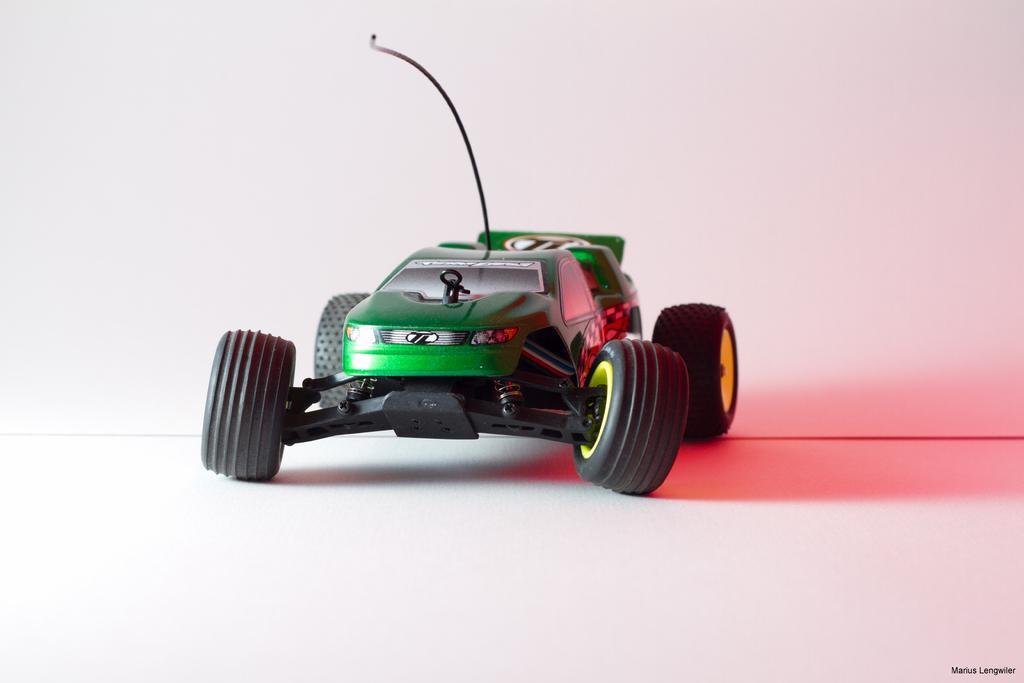Could you give a brief overview of what you see in this image? This is a toy car which is green in color. It has four tyres. The toy car is placed on the floor. From this car there is a wire. Behind this toy car there is a wall. 